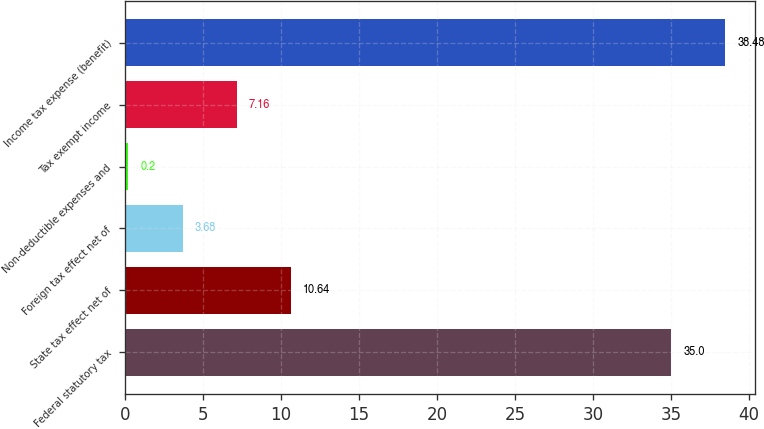Convert chart to OTSL. <chart><loc_0><loc_0><loc_500><loc_500><bar_chart><fcel>Federal statutory tax<fcel>State tax effect net of<fcel>Foreign tax effect net of<fcel>Non-deductible expenses and<fcel>Tax exempt income<fcel>Income tax expense (benefit)<nl><fcel>35<fcel>10.64<fcel>3.68<fcel>0.2<fcel>7.16<fcel>38.48<nl></chart> 